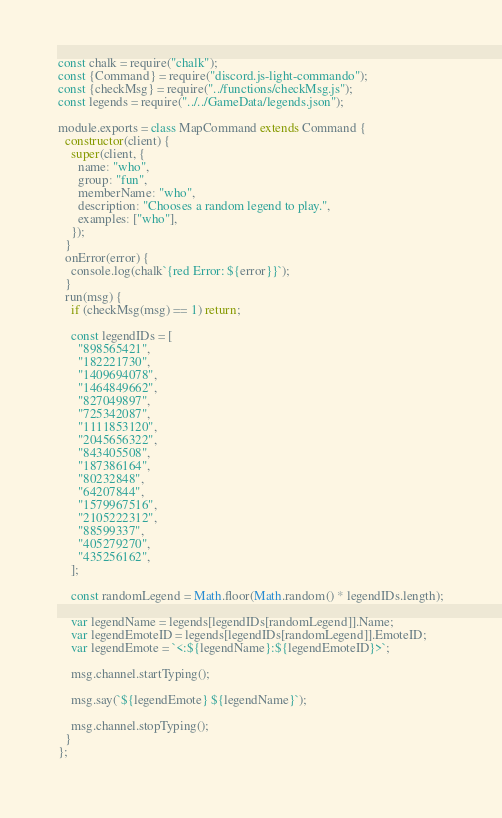Convert code to text. <code><loc_0><loc_0><loc_500><loc_500><_JavaScript_>const chalk = require("chalk");
const {Command} = require("discord.js-light-commando");
const {checkMsg} = require("../functions/checkMsg.js");
const legends = require("../../GameData/legends.json");

module.exports = class MapCommand extends Command {
  constructor(client) {
    super(client, {
      name: "who",
      group: "fun",
      memberName: "who",
      description: "Chooses a random legend to play.",
      examples: ["who"],
    });
  }
  onError(error) {
    console.log(chalk`{red Error: ${error}}`);
  }
  run(msg) {
    if (checkMsg(msg) == 1) return;

    const legendIDs = [
      "898565421",
      "182221730",
      "1409694078",
      "1464849662",
      "827049897",
      "725342087",
      "1111853120",
      "2045656322",
      "843405508",
      "187386164",
      "80232848",
      "64207844",
      "1579967516",
      "2105222312",
      "88599337",
      "405279270",
      "435256162",
    ];

    const randomLegend = Math.floor(Math.random() * legendIDs.length);

    var legendName = legends[legendIDs[randomLegend]].Name;
    var legendEmoteID = legends[legendIDs[randomLegend]].EmoteID;
    var legendEmote = `<:${legendName}:${legendEmoteID}>`;

    msg.channel.startTyping();

    msg.say(`${legendEmote} ${legendName}`);

    msg.channel.stopTyping();
  }
};
</code> 